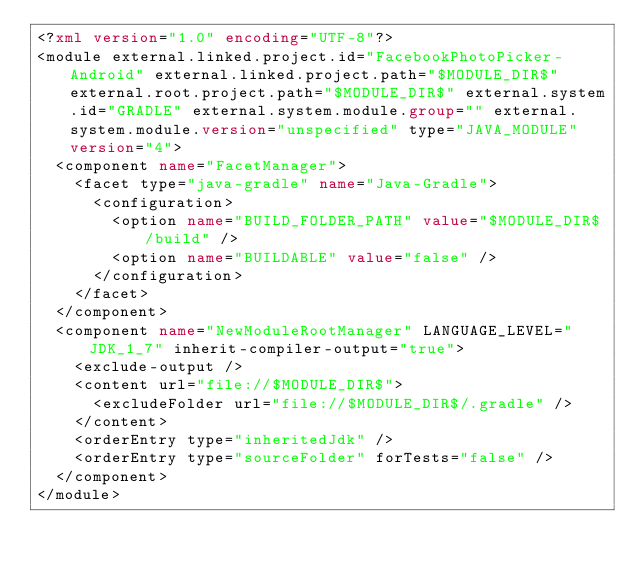Convert code to text. <code><loc_0><loc_0><loc_500><loc_500><_XML_><?xml version="1.0" encoding="UTF-8"?>
<module external.linked.project.id="FacebookPhotoPicker-Android" external.linked.project.path="$MODULE_DIR$" external.root.project.path="$MODULE_DIR$" external.system.id="GRADLE" external.system.module.group="" external.system.module.version="unspecified" type="JAVA_MODULE" version="4">
  <component name="FacetManager">
    <facet type="java-gradle" name="Java-Gradle">
      <configuration>
        <option name="BUILD_FOLDER_PATH" value="$MODULE_DIR$/build" />
        <option name="BUILDABLE" value="false" />
      </configuration>
    </facet>
  </component>
  <component name="NewModuleRootManager" LANGUAGE_LEVEL="JDK_1_7" inherit-compiler-output="true">
    <exclude-output />
    <content url="file://$MODULE_DIR$">
      <excludeFolder url="file://$MODULE_DIR$/.gradle" />
    </content>
    <orderEntry type="inheritedJdk" />
    <orderEntry type="sourceFolder" forTests="false" />
  </component>
</module></code> 